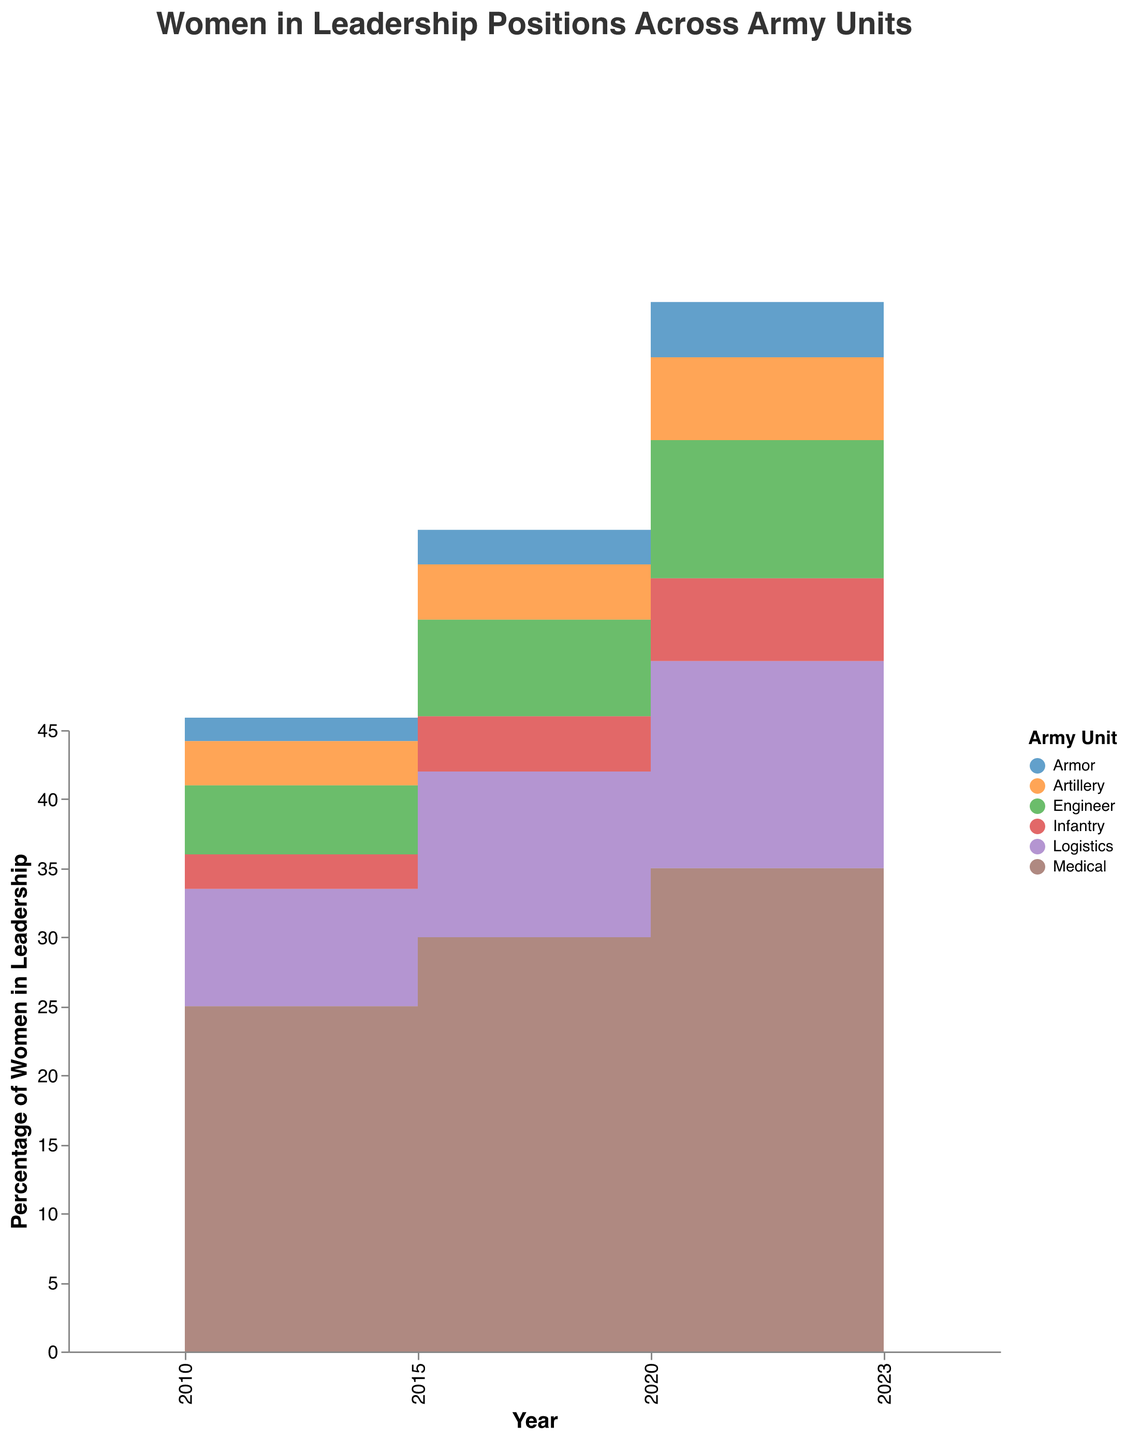What is the title of the figure? The title of the figure is typically at the top and states the main focus of the chart. In this figure, it is clearly printed as "Women in Leadership Positions Across Army Units."
Answer: Women in Leadership Positions Across Army Units Which year shows the highest percentage of women in leadership in Medical units? To determine this, look at the Medical unit's color representation and trace it through the different years. The highest point is in 2023, with 40%.
Answer: 2023 How has the percentage of women in leadership positions in the Infantry unit changed from 2010 to 2023? First, identify the percentage in 2010 for Infantry, which is 2.5%, and then in 2023, which is 8%. The change can be calculated by subtracting the 2010 value from the 2023 value: 8 - 2.5 = 5.5.
Answer: 5.5% Which unit has shown the most consistent growth in the percentage of women in leadership from 2010 to 2023? By examining the slopes of the step areas for each unit, the Medical unit demonstrates the most consistent growth, showing regular increases every few years.
Answer: Medical In 2020, which unit had the second-highest percentage of women in leadership roles? By inspecting the graph for the year 2020, the Logistics unit has 15%, which is the second-highest after Medical at 35%.
Answer: Logistics What is the total increase in the percentage of women in leadership roles in the Armor unit from 2010 to 2023? Calculate the difference between the 2023 value (6.0%) and the 2010 value (1.7%): 6.0 - 1.7 = 4.3.
Answer: 4.3% Compare the percentage increase of women in leadership in the Engineer unit between 2015 and 2023. Subtract the 2015 value (7.0%) from the 2023 value (12.0%) to find the difference: 12.0 - 7.0 = 5, which is then divided by the 2015 value to find the percentage increase: (5/7.0) * 100 ≈ 71.43%.
Answer: 71.43% How does the growth pattern in the Artillery unit compare to that of the Engineer unit? The Artillery unit increases from 3.2% (2010) to 8.5% (2023), while the Engineer unit moves from 5.0% (2010) to 12.0% (2023). Both show growth, but the Engineer unit’s growth is slightly steeper, indicating more increase in the percentage of women.
Answer: Engineer shows steeper growth What is the median percentage of women in leadership positions in Logistics across all years? To find the median, list the percentages for Logistics: 8.5, 12.0, 15.0, and 20.0. Since there are four values, the median is the average of the two middle values: (12.0 + 15.0) / 2 = 13.5.
Answer: 13.5% Which unit shows the largest absolute increase in the percentage of women in leadership from 2010 to 2023? The Medical unit increases from 25% in 2010 to 40% in 2023, an absolute increase of 15%, which is larger than any other unit in the figure.
Answer: Medical 